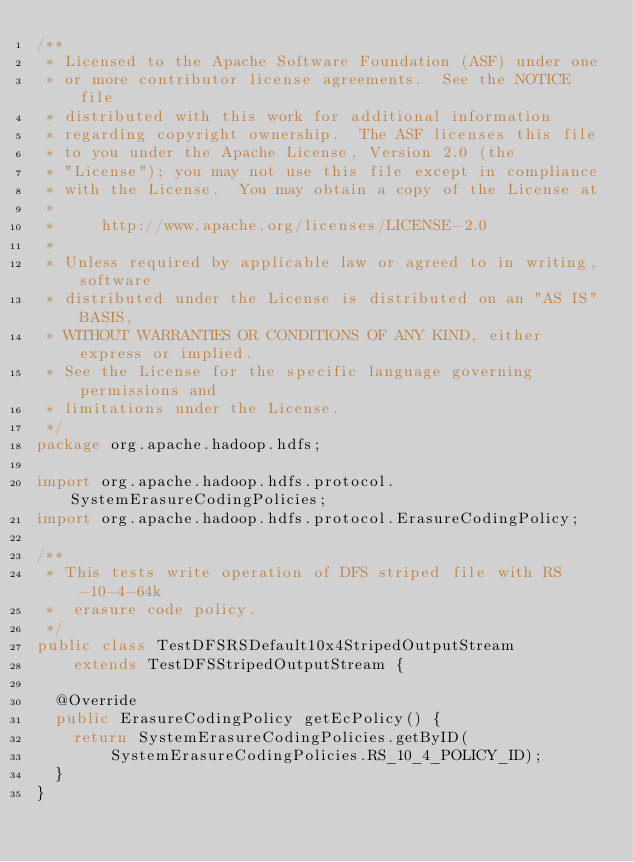<code> <loc_0><loc_0><loc_500><loc_500><_Java_>/**
 * Licensed to the Apache Software Foundation (ASF) under one
 * or more contributor license agreements.  See the NOTICE file
 * distributed with this work for additional information
 * regarding copyright ownership.  The ASF licenses this file
 * to you under the Apache License, Version 2.0 (the
 * "License"); you may not use this file except in compliance
 * with the License.  You may obtain a copy of the License at
 *
 *     http://www.apache.org/licenses/LICENSE-2.0
 *
 * Unless required by applicable law or agreed to in writing, software
 * distributed under the License is distributed on an "AS IS" BASIS,
 * WITHOUT WARRANTIES OR CONDITIONS OF ANY KIND, either express or implied.
 * See the License for the specific language governing permissions and
 * limitations under the License.
 */
package org.apache.hadoop.hdfs;

import org.apache.hadoop.hdfs.protocol.SystemErasureCodingPolicies;
import org.apache.hadoop.hdfs.protocol.ErasureCodingPolicy;

/**
 * This tests write operation of DFS striped file with RS-10-4-64k
 *  erasure code policy.
 */
public class TestDFSRSDefault10x4StripedOutputStream
    extends TestDFSStripedOutputStream {

  @Override
  public ErasureCodingPolicy getEcPolicy() {
    return SystemErasureCodingPolicies.getByID(
        SystemErasureCodingPolicies.RS_10_4_POLICY_ID);
  }
}
</code> 